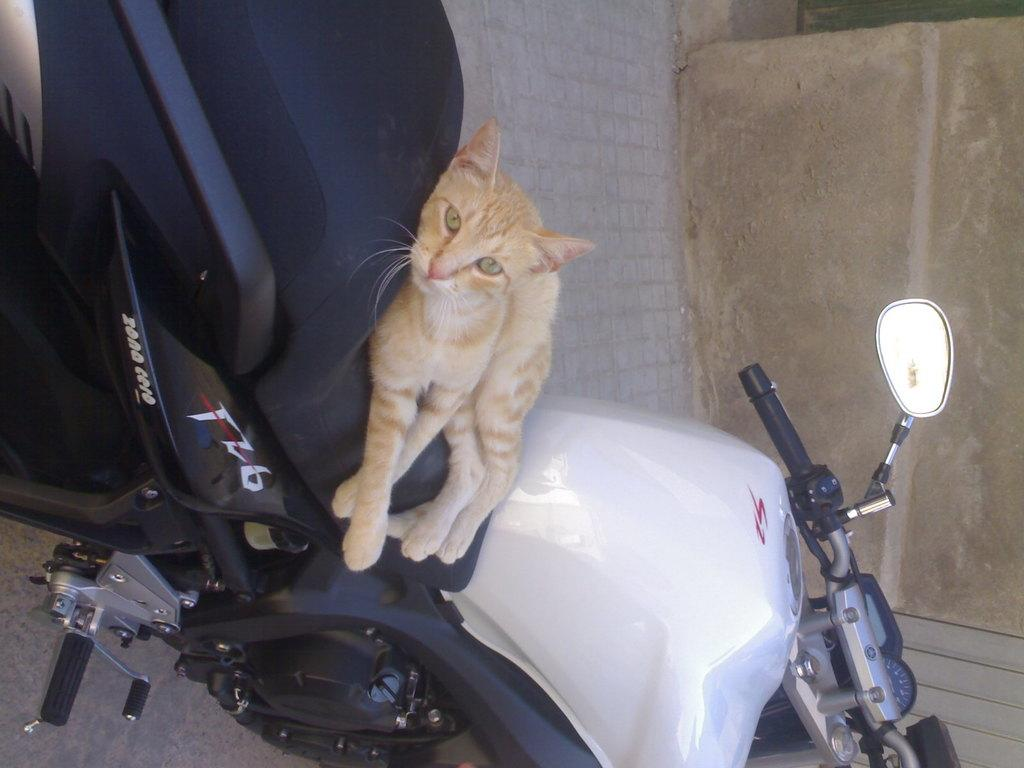What animal can be seen in the image? There is a cat in the image. Where is the cat positioned in the image? The cat is laying on a motorbike. What can you tell about the color of the motorbike? The motorbike is in black and white color. What features can be identified on the motorbike? The motorbike has a handle, a meter reading, a mirror, and a stand. What type of silk is being used to cover the motorbike in the image? There is no silk present in the image; the motorbike is in black and white color. Can you tell me the grade of the turkey that is sitting on the handle of the motorbike? There is no turkey present in the image; the motorbike features a cat laying on it. 